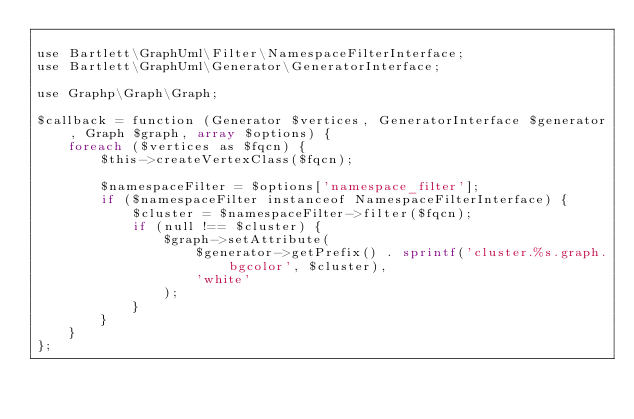Convert code to text. <code><loc_0><loc_0><loc_500><loc_500><_PHP_>
use Bartlett\GraphUml\Filter\NamespaceFilterInterface;
use Bartlett\GraphUml\Generator\GeneratorInterface;

use Graphp\Graph\Graph;

$callback = function (Generator $vertices, GeneratorInterface $generator, Graph $graph, array $options) {
    foreach ($vertices as $fqcn) {
        $this->createVertexClass($fqcn);

        $namespaceFilter = $options['namespace_filter'];
        if ($namespaceFilter instanceof NamespaceFilterInterface) {
            $cluster = $namespaceFilter->filter($fqcn);
            if (null !== $cluster) {
                $graph->setAttribute(
                    $generator->getPrefix() . sprintf('cluster.%s.graph.bgcolor', $cluster),
                    'white'
                );
            }
        }
    }
};
</code> 